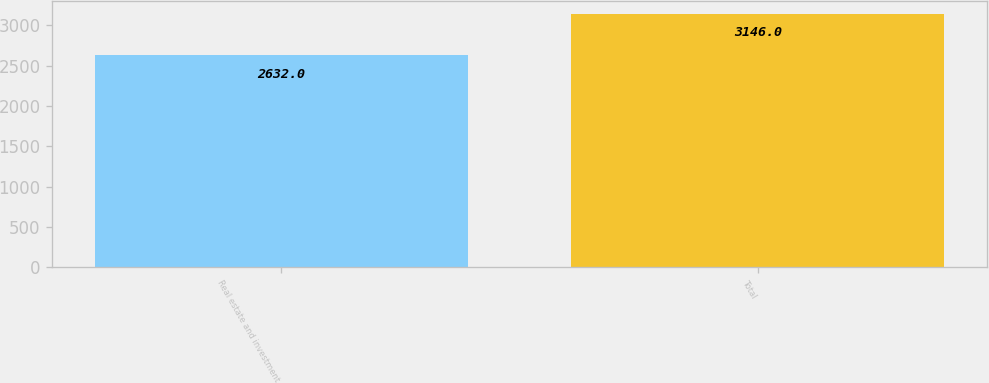Convert chart. <chart><loc_0><loc_0><loc_500><loc_500><bar_chart><fcel>Real estate and investment<fcel>Total<nl><fcel>2632<fcel>3146<nl></chart> 